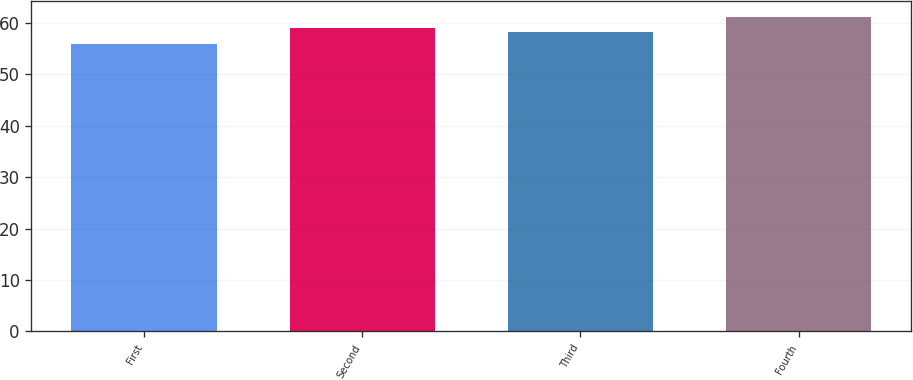Convert chart to OTSL. <chart><loc_0><loc_0><loc_500><loc_500><bar_chart><fcel>First<fcel>Second<fcel>Third<fcel>Fourth<nl><fcel>55.86<fcel>58.98<fcel>58.25<fcel>61.2<nl></chart> 